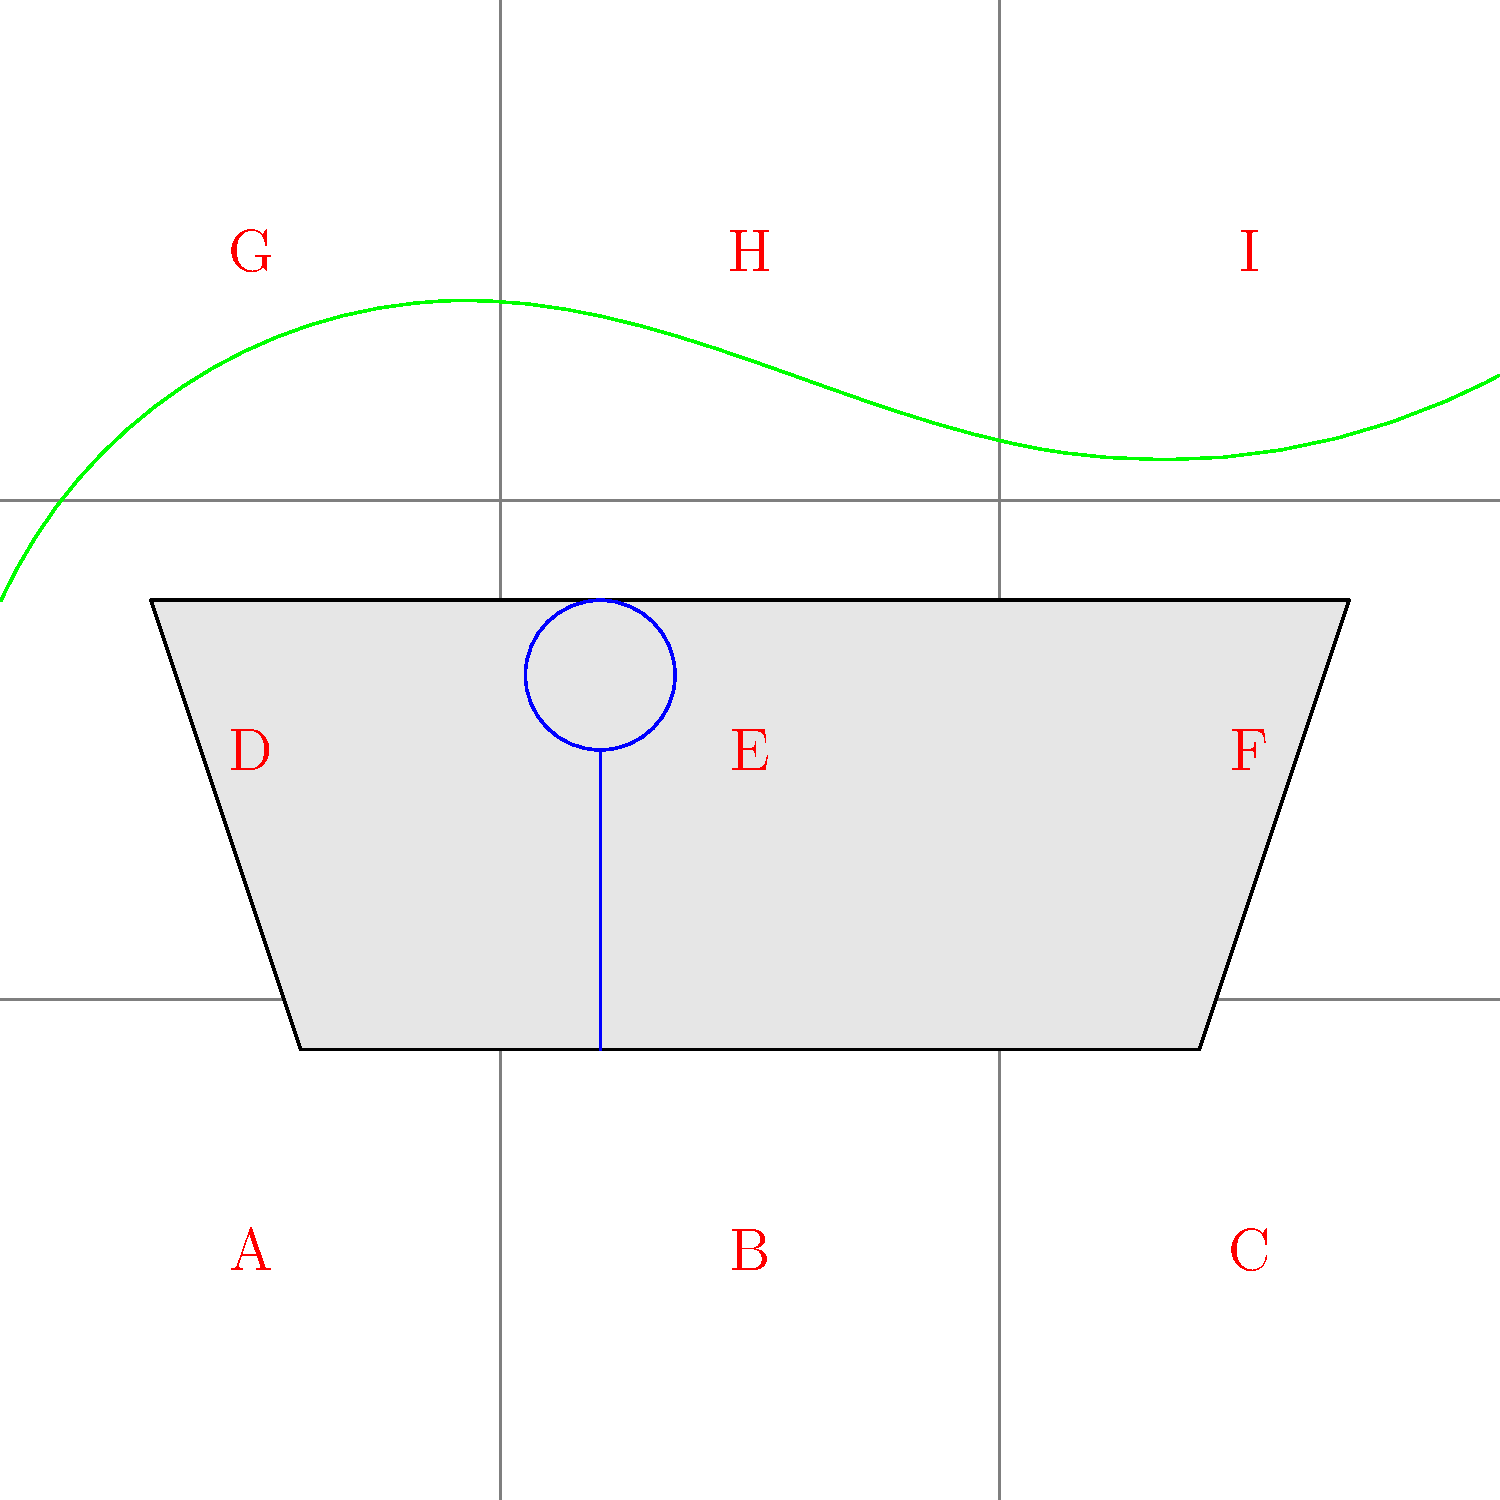In this scene inspired by the Mongolian landscape, which point on the Rule of Thirds grid would be most effective for placing the main character to create a visually compelling composition that Lkhagvadulam Purev-Ochir might appreciate in her films? To answer this question, let's consider the principles of the Rule of Thirds and how they might apply to Mongolian cinema, particularly in the style of Lkhagvadulam Purev-Ochir:

1. The Rule of Thirds divides the frame into a 3x3 grid, creating nine equal parts.
2. The four intersection points of this grid are considered powerful focal points in composition.
3. In the given image, these points are labeled D, F, G, and I.
4. Mongolian cinema often emphasizes the relationship between characters and their environment.
5. Lkhagvadulam Purev-Ochir's work is known for its thoughtful composition and connection to Mongolian culture.
6. In this scene, we have a traditional Mongolian yurt (ger) and mountains in the background, representing the landscape.
7. The most compelling composition would likely place the character in relation to both the ger and the landscape.
8. Point F is located at the intersection of the right vertical third and the horizontal center line.
9. Placing the character at point F would:
   a) Position them in relation to the ger, suggesting a connection to traditional life.
   b) Leave space on the left for the viewer to see the ger and mountains, establishing context.
   c) Create a balanced composition that draws the eye across the frame.
10. This composition aligns with Purev-Ochir's style of visually storytelling that connects characters to their cultural and physical environment.

Therefore, point F would be the most effective placement for the main character in this composition.
Answer: F 